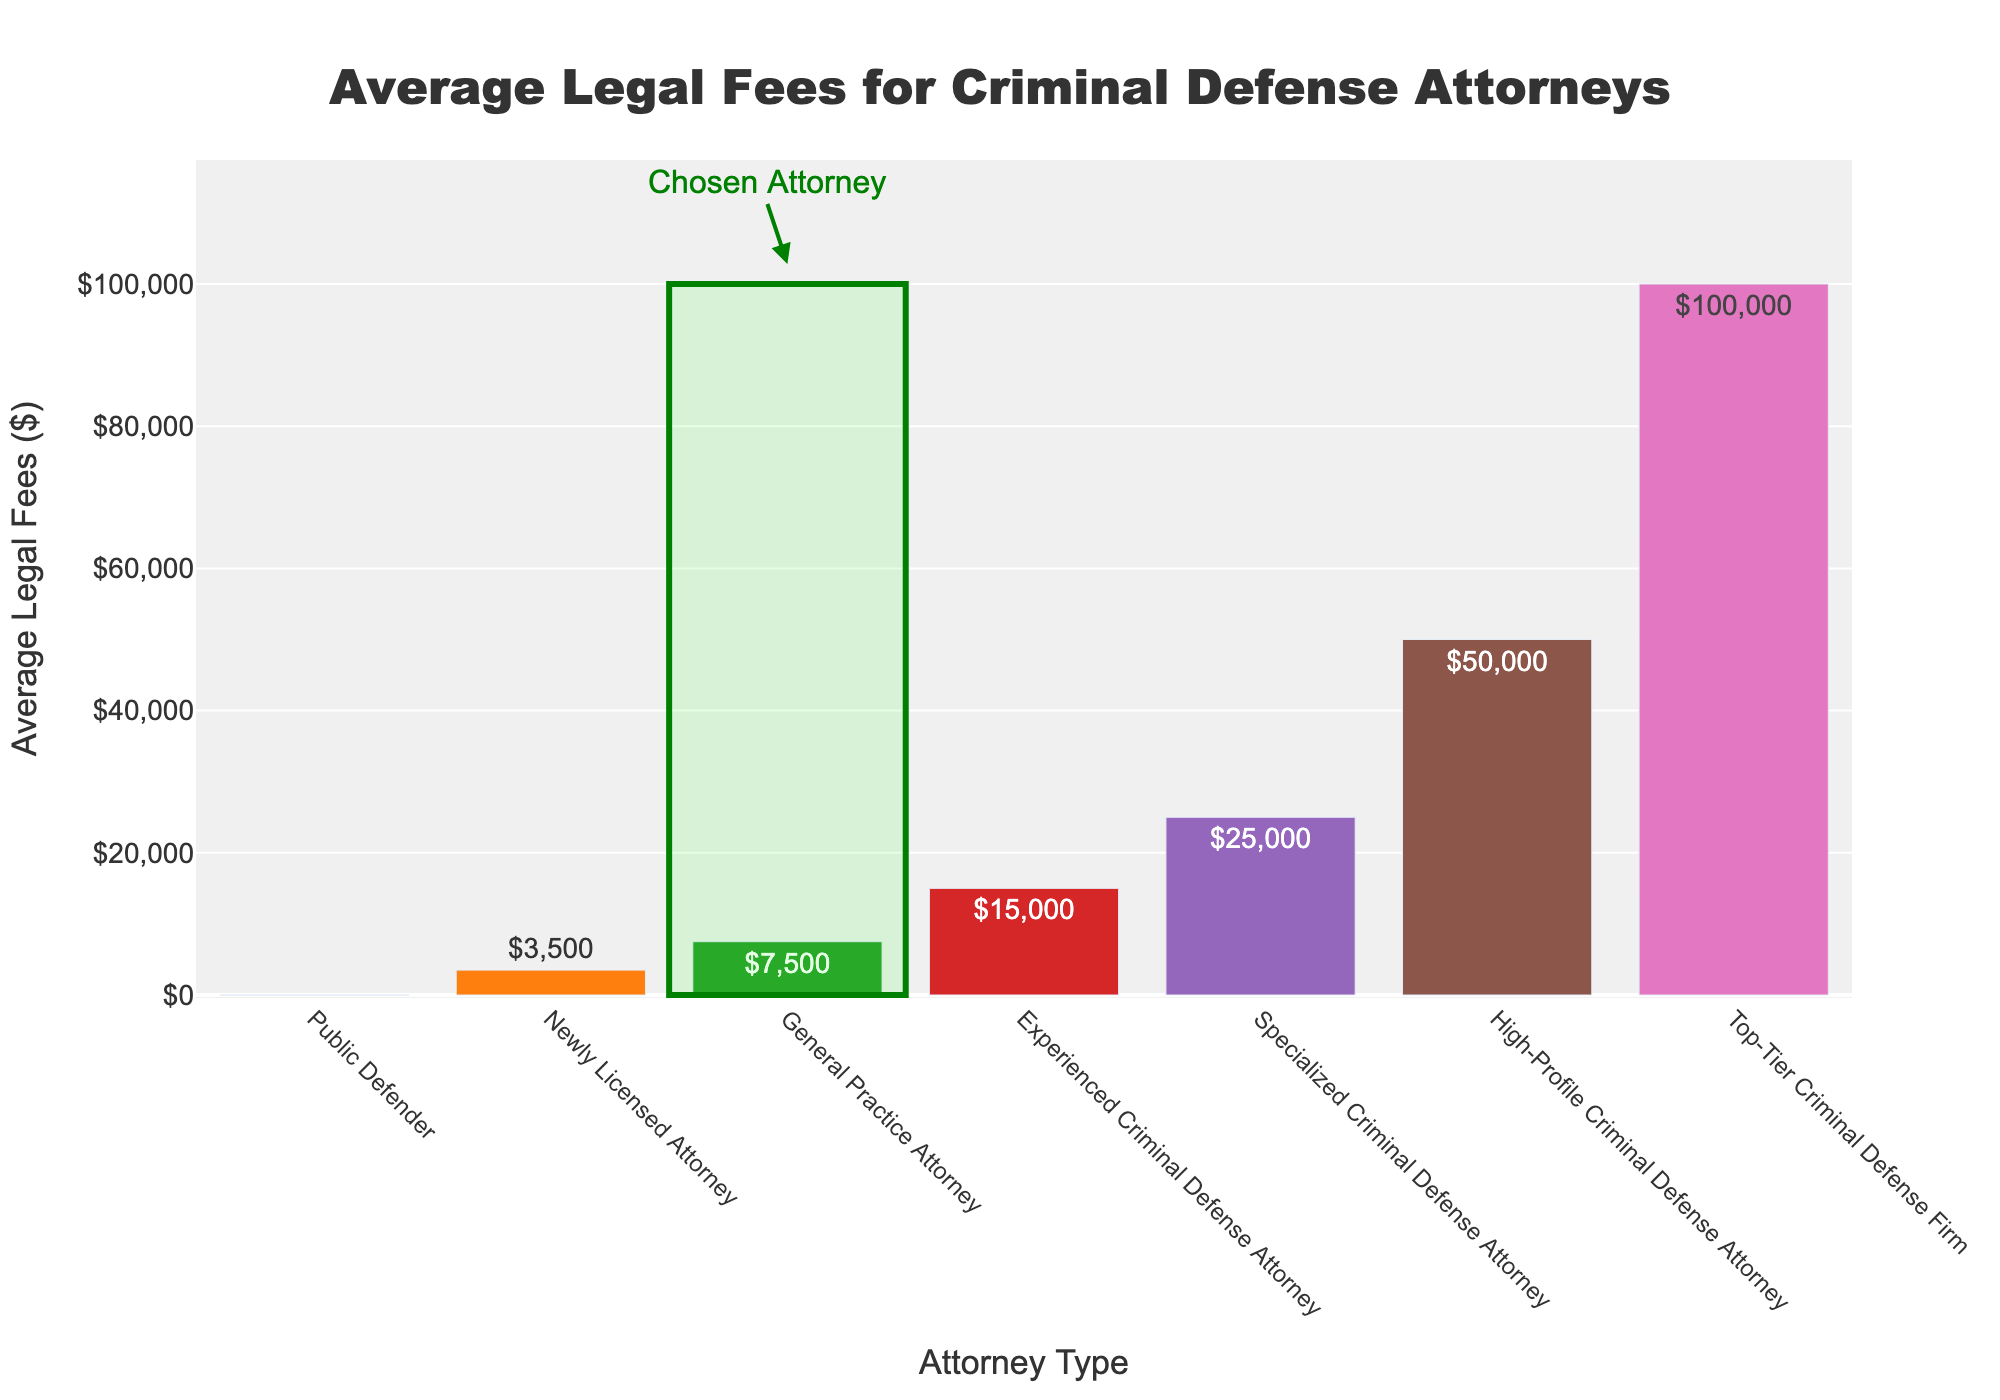What's the range of legal fees for criminal defense attorneys in the plot? The range of legal fees is determined by subtracting the lowest fee from the highest fee. The lowest fee is $0 (Public Defender) and the highest fee is $100,000 (Top-Tier Criminal Defense Firm). So, the range is $100,000 - $0.
Answer: $100,000 Which attorney type has the highest average legal fees? By observing the heights of the bars, the Top-Tier Criminal Defense Firm has the highest bar, indicating the highest average legal fees.
Answer: Top-Tier Criminal Defense Firm What is the difference in average legal fees between a Newly Licensed Attorney and a High-Profile Criminal Defense Attorney? The average legal fees for a Newly Licensed Attorney are $3,500, and for a High-Profile Criminal Defense Attorney, it is $50,000. The difference can be calculated by subtracting $3,500 from $50,000.
Answer: $46,500 Which attorney type is highlighted in the figure and why? The highlighted attorney type falls under the Experienced Criminal Defense Attorney bar. It is visually marked with a green rectangle and arrow annotation pointing to it.
Answer: Experienced Criminal Defense Attorney How many types of criminal defense attorneys have average legal fees below $10,000? The bars representing Public Defender, Newly Licensed Attorney, and General Practice Attorney all have average legal fees below $10,000. Counting these bars gives a total of three.
Answer: 3 Is there any attorney type with average legal fees exactly midway between the highest and the lowest fees? The average of the highest ($100,000) and the lowest ($0) fees is $50,000. By observing the figure, the only attorney type with this average fee is the High-Profile Criminal Defense Attorney.
Answer: High-Profile Criminal Defense Attorney What's the average legal fee among the General Practice Attorney, Experienced Criminal Defense Attorney, and Specialized Criminal Defense Attorney types? The average legal fees for these types are $7,500, $15,000, and $25,000 respectively. The average of these values is calculated as ($7,500 + $15,000 + $25,000) / 3.
Answer: $15,833.33 By how much do the average legal fees of a Specialized Criminal Defense Attorney exceed those of a General Practice Attorney? The average legal fees for a Specialized Criminal Defense Attorney are $25,000, and for a General Practice Attorney, it is $7,500. The difference is $25,000 - $7,500.
Answer: $17,500 Which types of attorneys have linear positive incremental increases in legal fees? The incremental increase refers to a steadily increasing pattern across the attorney types. Observing the figure, progressions like Newly Licensed Attorney ($3,500) -> General Practice Attorney ($7,500) -> Experienced Criminal Defense Attorney ($15,000) -> Specialized Criminal Defense Attorney ($25,000) -> High-Profile Criminal Defense Attorney ($50,000) -> Top-Tier Criminal Defense Firm ($100,000) reflect a clear linear positive increment.
Answer: Newly Licensed Attorney, General Practice Attorney, Experienced Criminal Defense Attorney, Specialized Criminal Defense Attorney, High-Profile Criminal Defense Attorney, Top-Tier Criminal Defense Firm 